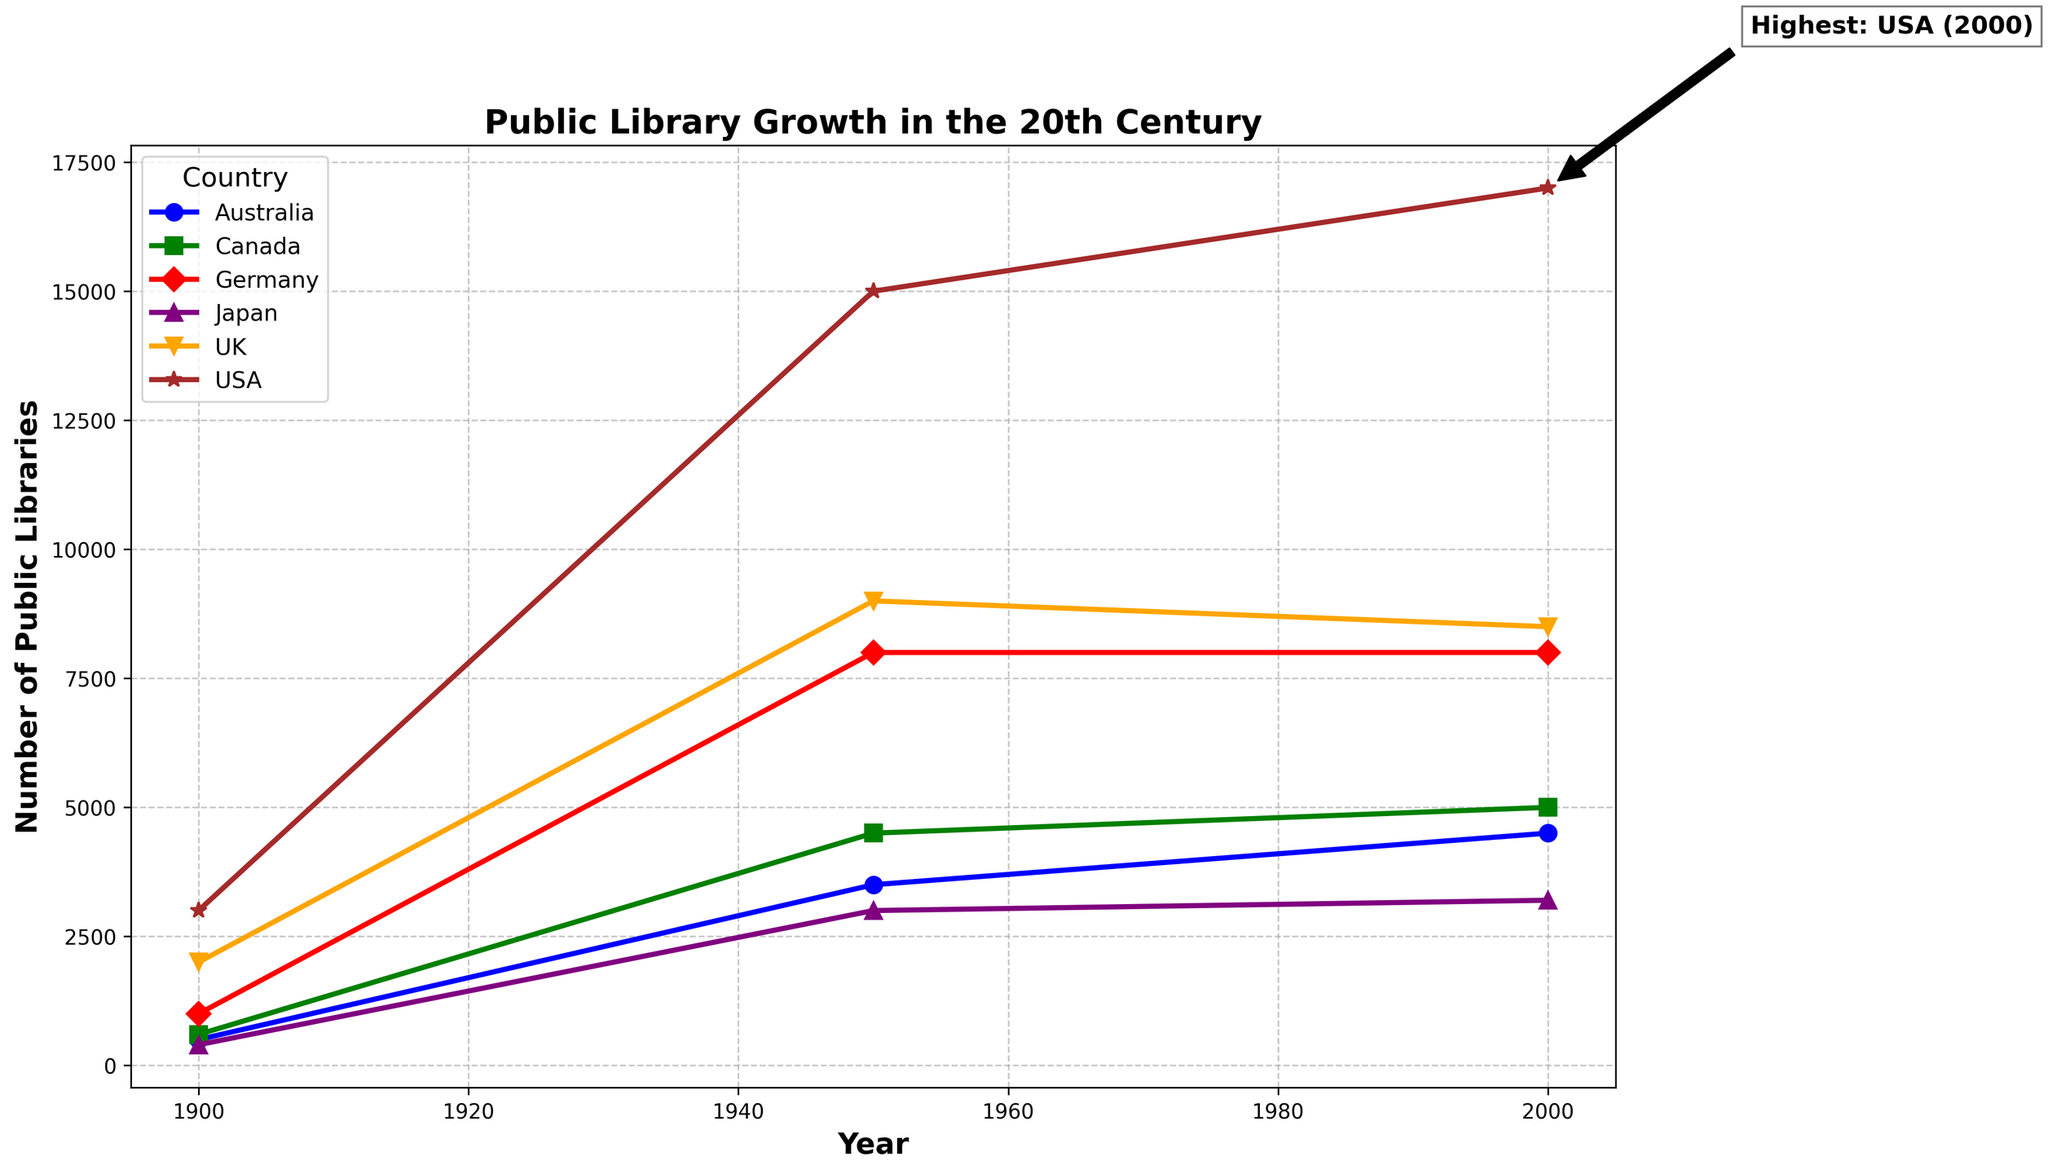Which country had the highest number of public libraries in the 20th century? The annotation in the figure indicates that the country with the highest number of public libraries is the USA in the year 1950. This is highlighted with a text annotation.
Answer: USA What is the total number of public libraries across all countries in the year 1900? To find the total, sum the number of public libraries in 1900 for each country: USA (3000), UK (2000), Germany (1000), Australia (500), Japan (400), and Canada (600). Total = 3000 + 2000 + 1000 + 500 + 400 + 600 = 7500
Answer: 7500 How did the number of public libraries in the UK change from 1950 to 2000? To find the change, subtract the number of public libraries in 2000 from that in 1950 for the UK: 9000 (1950) - 8500 (2000) = 500. There is a decrease of 500 libraries.
Answer: Decreased by 500 Which three countries had a moderate influence of economic policies in the year 2000, and how many public libraries did each have? From the data given, the countries with a moderate influence in 2000 are USA (17000 libraries), Australia (4500 libraries), and Canada (5000 libraries). This information can be seen in both the figure and the table annotations.
Answer: USA: 17000, Australia: 4500, Canada: 5000 What is the average number of public libraries in Germany over the three periods (1900, 1950, 2000)? To calculate the average, sum the number of public libraries in Germany for the years 1900 (1000), 1950 (8000), and 2000 (8000), then divide by the number of periods: (1000 + 8000 + 8000) / 3 = 17000 / 3 ≈ 5667
Answer: 5667 Which country experienced the highest growth in the number of public libraries from 1900 to 1950? Calculate the growth for each country by subtracting the number of libraries in 1900 from that in 1950. USA: 15000-3000 = 12000; UK: 9000-2000 = 7000; Germany: 8000-1000 = 7000; Australia: 3500-500 = 3000; Japan: 3000-400 = 2600; Canada: 4500-600 = 3900. The USA experienced the highest growth.
Answer: USA Which country had the least number of public libraries in the year 2000? By comparing the numbers for 2000, Japan had the least with 3200 public libraries.
Answer: Japan Compare the number of public libraries in Australia and Japan in 1950. Which country had more, and by how much? In 1950, Australia had 3500 public libraries, and Japan had 3000. Australia had 500 more libraries than Japan.
Answer: Australia by 500 